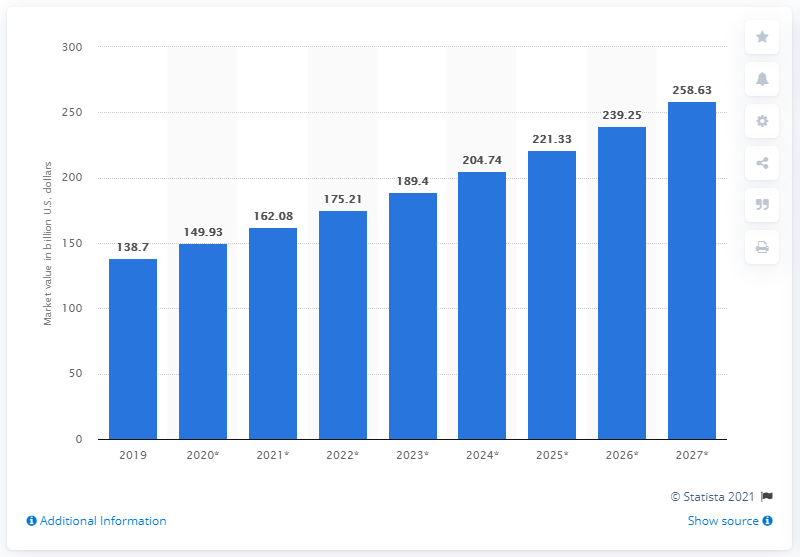Highlight a few significant elements in this photo. In 2019, the global eyewear market was worth approximately 138.7 billion dollars. According to a forecast, the global eyewear market is expected to reach a value of 258.63 billion by 2027. 